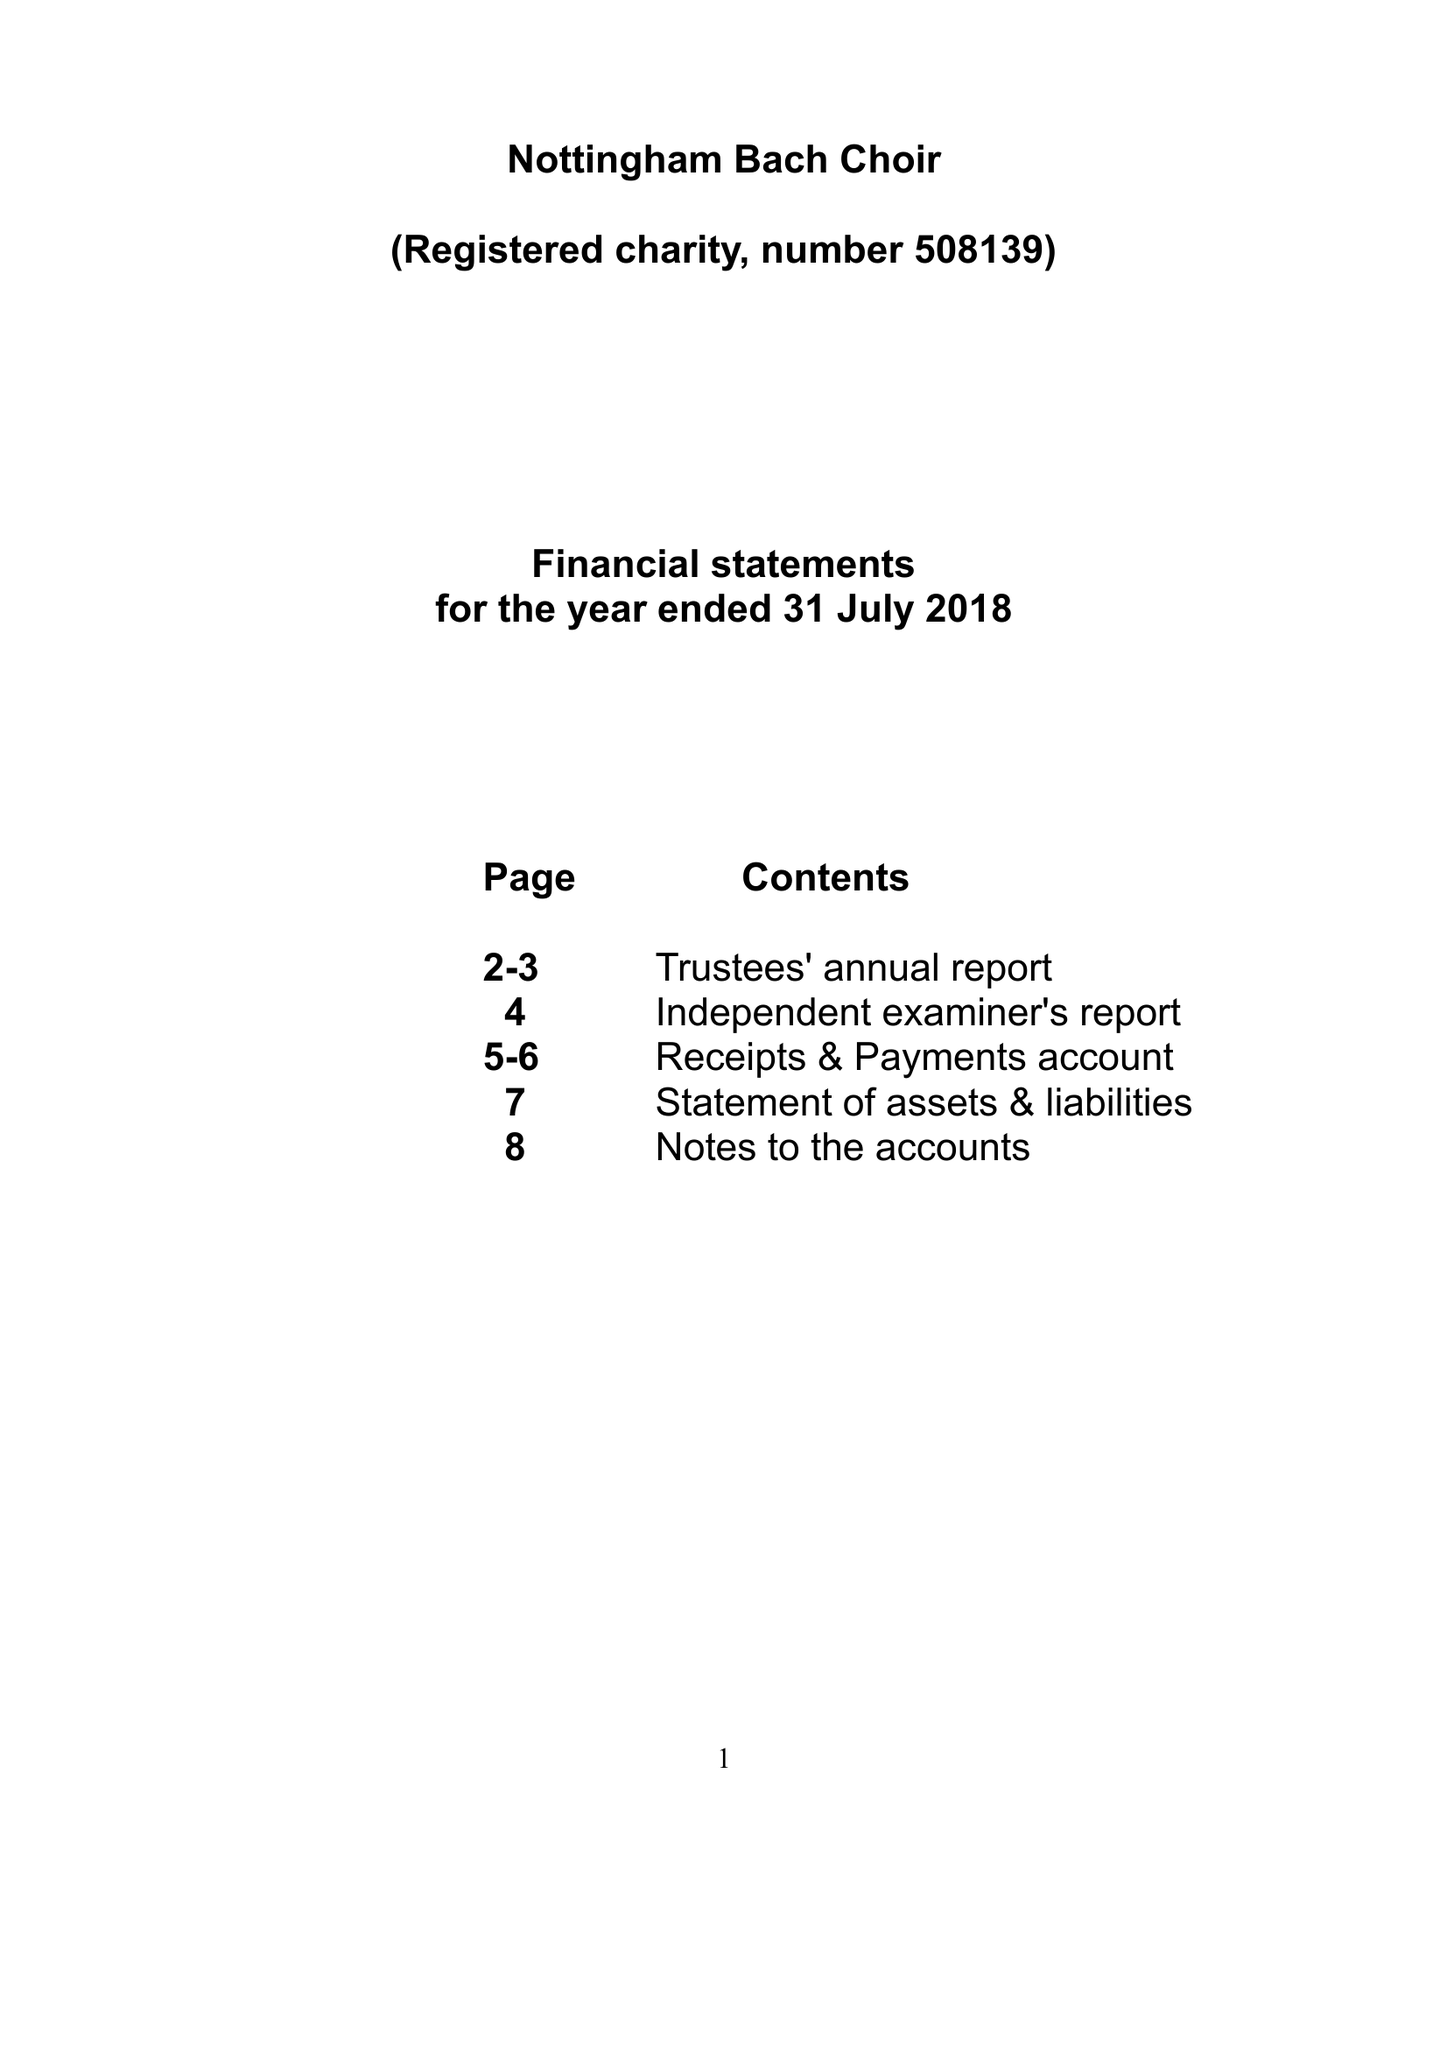What is the value for the charity_number?
Answer the question using a single word or phrase. 508139 